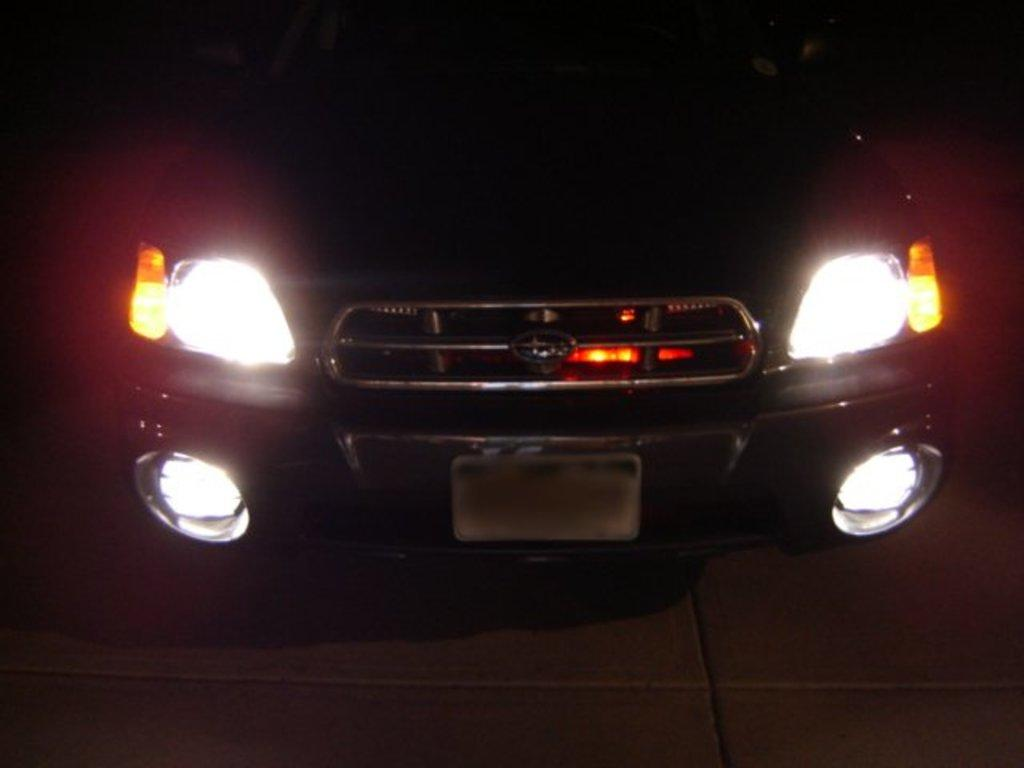What is the main subject of the image? The main subject of the image is a car. Can you describe the position of the car in the image? The car is in the center of the image. What type of toothpaste is being used to clean the car in the image? There is no toothpaste present in the image, and the car is not being cleaned. What emotion is being expressed by the car in the image? The car is an inanimate object and cannot express emotions like love. 